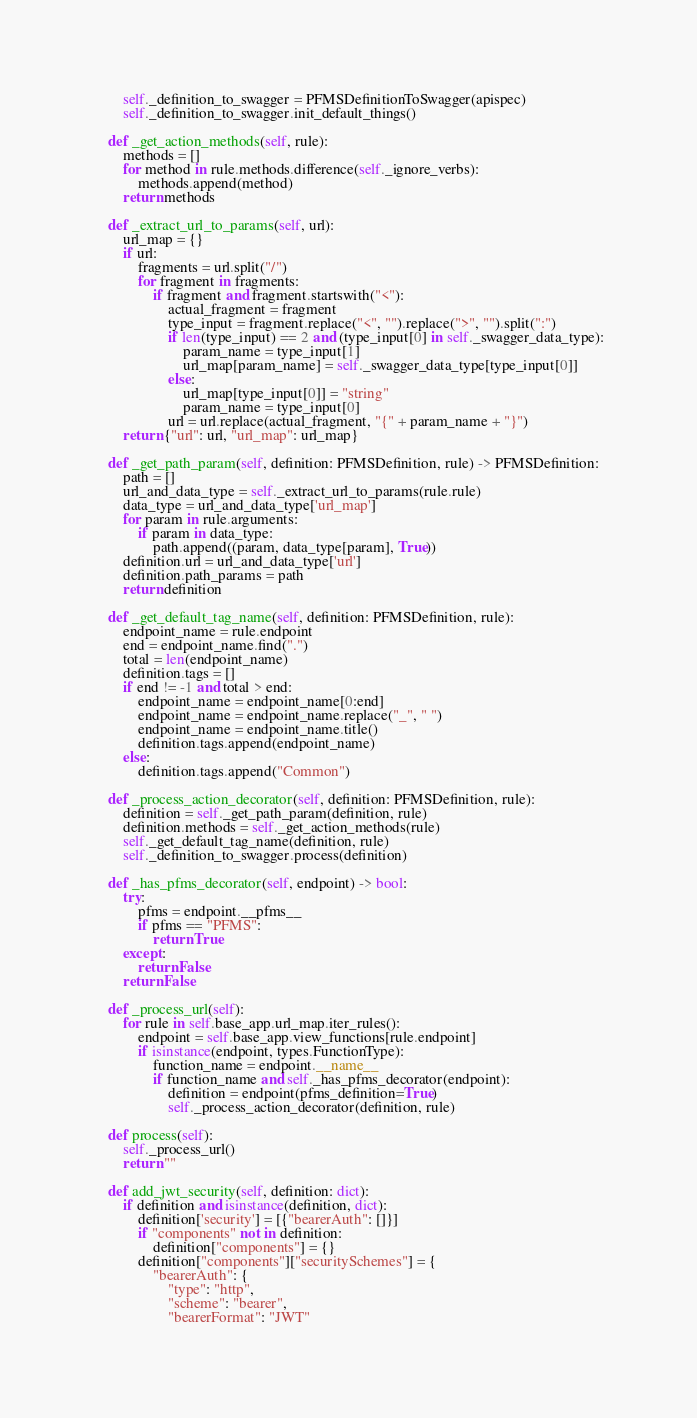Convert code to text. <code><loc_0><loc_0><loc_500><loc_500><_Python_>        self._definition_to_swagger = PFMSDefinitionToSwagger(apispec)
        self._definition_to_swagger.init_default_things()

    def _get_action_methods(self, rule):
        methods = []
        for method in rule.methods.difference(self._ignore_verbs):
            methods.append(method)
        return methods

    def _extract_url_to_params(self, url):
        url_map = {}
        if url:
            fragments = url.split("/")
            for fragment in fragments:
                if fragment and fragment.startswith("<"):
                    actual_fragment = fragment
                    type_input = fragment.replace("<", "").replace(">", "").split(":")
                    if len(type_input) == 2 and (type_input[0] in self._swagger_data_type):
                        param_name = type_input[1]
                        url_map[param_name] = self._swagger_data_type[type_input[0]]
                    else:
                        url_map[type_input[0]] = "string"
                        param_name = type_input[0]
                    url = url.replace(actual_fragment, "{" + param_name + "}")
        return {"url": url, "url_map": url_map}

    def _get_path_param(self, definition: PFMSDefinition, rule) -> PFMSDefinition:
        path = []
        url_and_data_type = self._extract_url_to_params(rule.rule)
        data_type = url_and_data_type['url_map']
        for param in rule.arguments:
            if param in data_type:
                path.append((param, data_type[param], True))
        definition.url = url_and_data_type['url']
        definition.path_params = path
        return definition

    def _get_default_tag_name(self, definition: PFMSDefinition, rule):
        endpoint_name = rule.endpoint
        end = endpoint_name.find(".")
        total = len(endpoint_name)
        definition.tags = []
        if end != -1 and total > end:
            endpoint_name = endpoint_name[0:end]
            endpoint_name = endpoint_name.replace("_", " ")
            endpoint_name = endpoint_name.title()
            definition.tags.append(endpoint_name)
        else:
            definition.tags.append("Common")

    def _process_action_decorator(self, definition: PFMSDefinition, rule):
        definition = self._get_path_param(definition, rule)
        definition.methods = self._get_action_methods(rule)
        self._get_default_tag_name(definition, rule)
        self._definition_to_swagger.process(definition)

    def _has_pfms_decorator(self, endpoint) -> bool:
        try:
            pfms = endpoint.__pfms__
            if pfms == "PFMS":
                return True
        except:
            return False
        return False

    def _process_url(self):
        for rule in self.base_app.url_map.iter_rules():
            endpoint = self.base_app.view_functions[rule.endpoint]
            if isinstance(endpoint, types.FunctionType):
                function_name = endpoint.__name__
                if function_name and self._has_pfms_decorator(endpoint):
                    definition = endpoint(pfms_definition=True)
                    self._process_action_decorator(definition, rule)

    def process(self):
        self._process_url()
        return ""

    def add_jwt_security(self, definition: dict):
        if definition and isinstance(definition, dict):
            definition['security'] = [{"bearerAuth": []}]
            if "components" not in definition:
                definition["components"] = {}
            definition["components"]["securitySchemes"] = {
                "bearerAuth": {
                    "type": "http",
                    "scheme": "bearer",
                    "bearerFormat": "JWT"</code> 